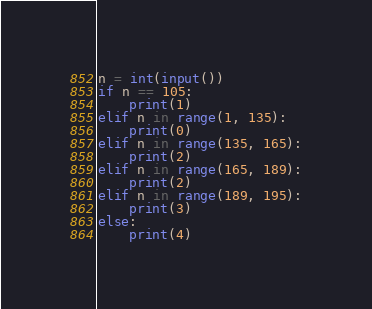Convert code to text. <code><loc_0><loc_0><loc_500><loc_500><_Python_>n = int(input())
if n == 105:
    print(1)
elif n in range(1, 135):
    print(0)
elif n in range(135, 165):
    print(2)
elif n in range(165, 189):
    print(2)
elif n in range(189, 195):
    print(3)
else:
    print(4)


</code> 